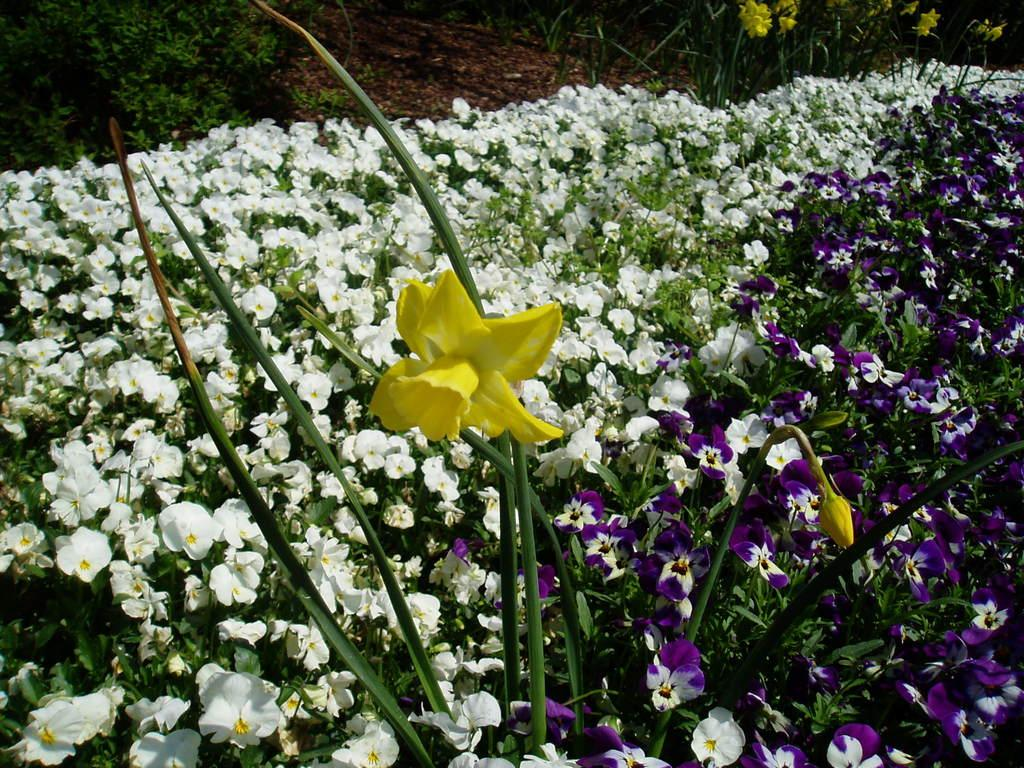What type of plants can be seen in the image? There are flowering plants in the picture. How are the flowering plants arranged in the image? The flowering plants resemble trees on the top left side of the image. Where is the fire hydrant located in the image? There is no fire hydrant present in the image. What part of the brain can be seen in the image? There is no brain present in the image; it features flowering plants resembling trees. 